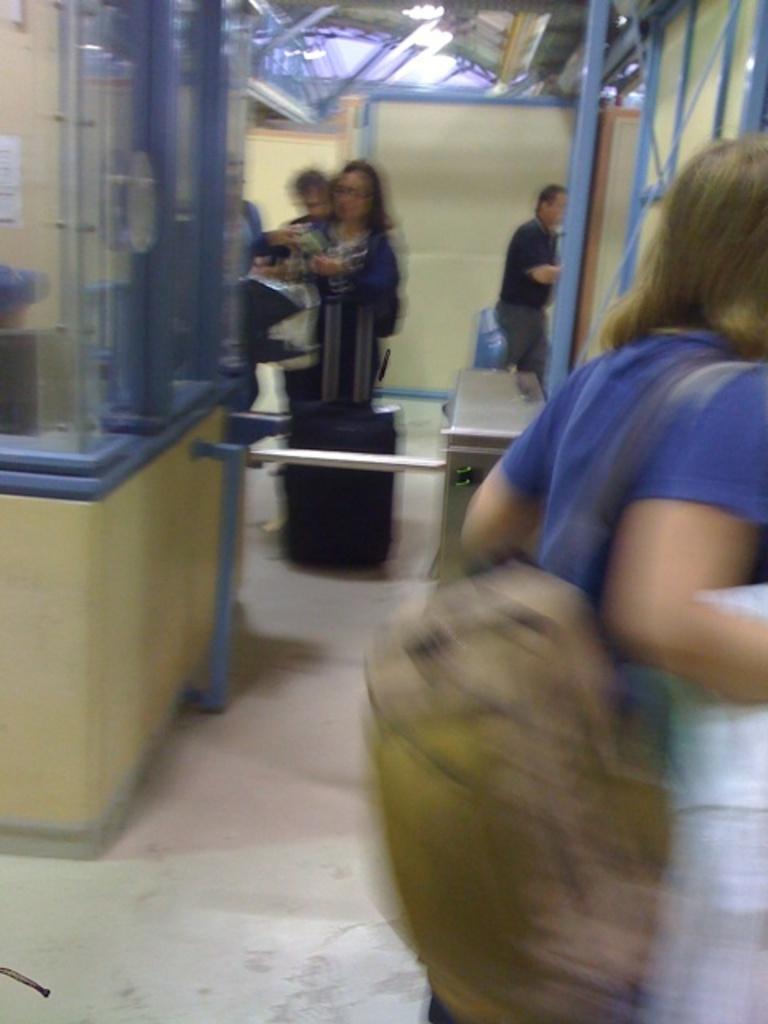How would you summarize this image in a sentence or two? In this picture there is a man who is standing near to the partition. In the back I can see some people who are standing near to the table and box. At the top I can see the shed. 